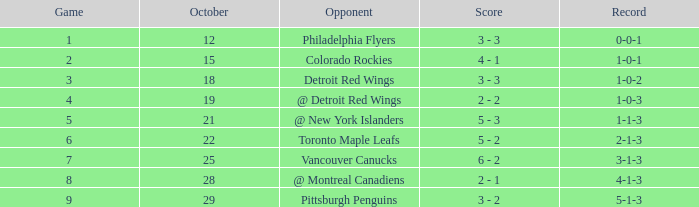Name the score for game more than 6 and before october 28 6 - 2. 